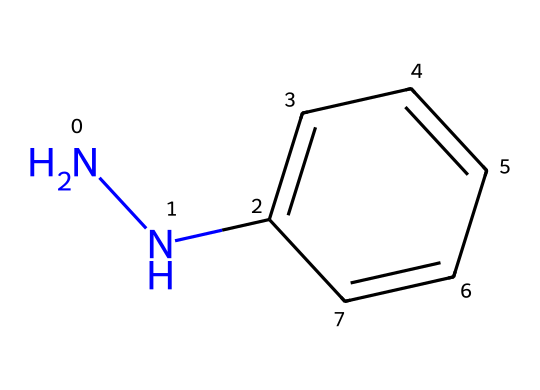What is the name of this chemical compound? The provided SMILES corresponds to a compound with a structure including a phenyl ring attached to a hydrazine functional group, which is known as phenylhydrazine.
Answer: phenylhydrazine How many carbon atoms are in the structure? By analyzing the structure, we see there are six carbon atoms in the phenyl ring and one carbon atom in the hydrazine part (since the nitrogen atoms are directly bonded to a carbon in the ring), totaling seven carbon atoms.
Answer: seven What is the total number of nitrogen atoms in this structure? The SMILES representation includes two nitrogen atoms in the hydrazine part (as seen in the NNC part), hence the total number of nitrogen atoms is two.
Answer: two What type of chemical bonding is primarily present in the phenylhydrazine structure? The predominant type of bonding found in the compound includes covalent bonds, as illustrated by the shared pairs of electrons between carbon, nitrogen, and hydrogen atoms.
Answer: covalent How does the structure of phenylhydrazine contribute to its reactivity? The presence of the hydrazine functional group increases the reactivity due to the electron-donating properties of the nitrogen atoms, making it more likely to participate in reactions such as hydrazone formation with carbonyl compounds.
Answer: increased reactivity What functional groups are present in this compound? The structure clearly showcases a hydrazine group (N-N) and a phenyl group (C6H5), making these the principal functional groups present in phenylhydrazine.
Answer: hydrazine and phenyl What type of chemical compound is phenylhydrazine classified as? Phenylhydrazine belongs to the class of organic compounds known as hydrazines, characterized by the presence of the nitrogen-nitrogen (N-N) bond in its structure.
Answer: hydrazine 